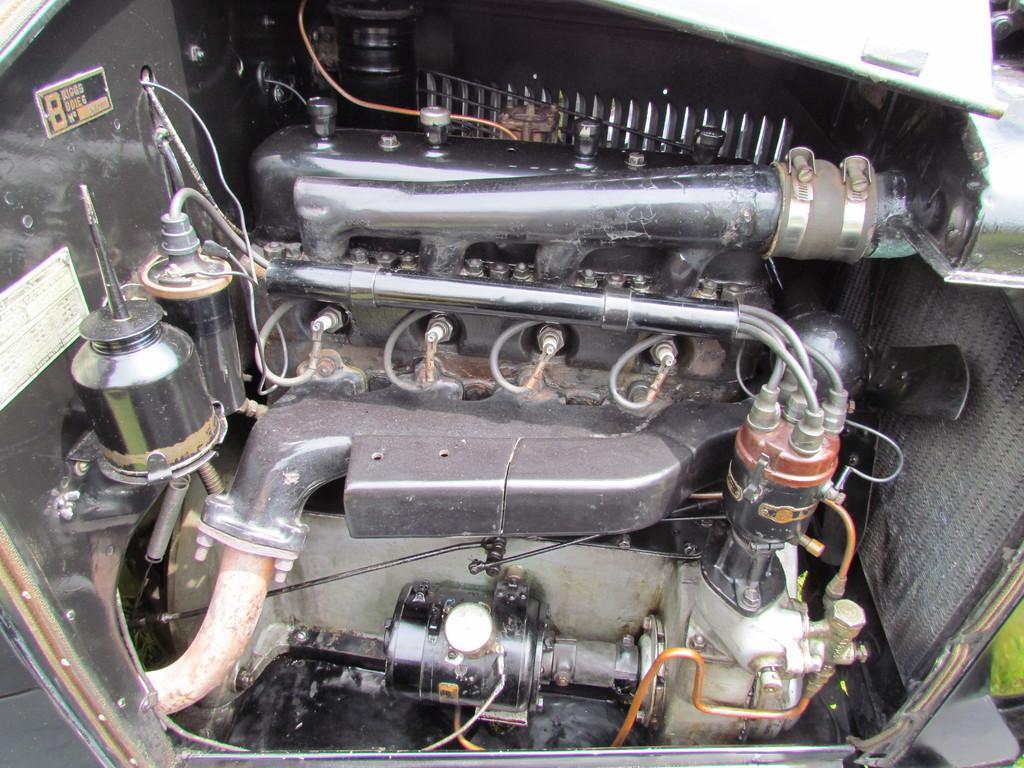Can you describe this image briefly? In this image we can see inside of a vehicle. There are pipes, wires, nuts and bolts. Also there is a plate with something written. And there are few other items. 